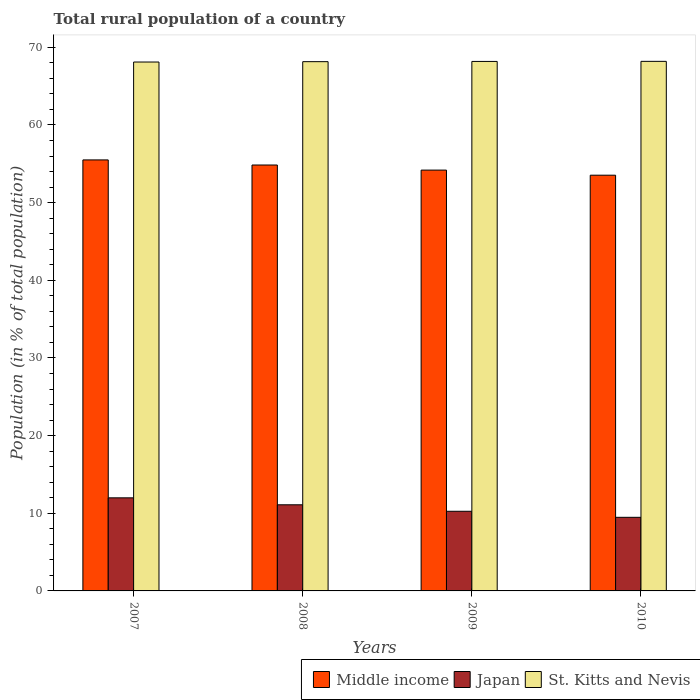How many groups of bars are there?
Give a very brief answer. 4. Are the number of bars per tick equal to the number of legend labels?
Ensure brevity in your answer.  Yes. How many bars are there on the 2nd tick from the left?
Provide a short and direct response. 3. What is the label of the 3rd group of bars from the left?
Make the answer very short. 2009. In how many cases, is the number of bars for a given year not equal to the number of legend labels?
Your answer should be compact. 0. What is the rural population in Japan in 2009?
Provide a succinct answer. 10.26. Across all years, what is the maximum rural population in Middle income?
Your answer should be very brief. 55.5. Across all years, what is the minimum rural population in St. Kitts and Nevis?
Offer a very short reply. 68.11. In which year was the rural population in St. Kitts and Nevis maximum?
Keep it short and to the point. 2010. In which year was the rural population in Japan minimum?
Your answer should be very brief. 2010. What is the total rural population in Japan in the graph?
Provide a succinct answer. 42.81. What is the difference between the rural population in Japan in 2008 and that in 2009?
Your answer should be compact. 0.83. What is the difference between the rural population in Middle income in 2007 and the rural population in Japan in 2008?
Offer a terse response. 44.41. What is the average rural population in St. Kitts and Nevis per year?
Give a very brief answer. 68.16. In the year 2009, what is the difference between the rural population in St. Kitts and Nevis and rural population in Japan?
Ensure brevity in your answer.  57.93. In how many years, is the rural population in Middle income greater than 4 %?
Offer a very short reply. 4. What is the ratio of the rural population in Middle income in 2008 to that in 2009?
Make the answer very short. 1.01. What is the difference between the highest and the second highest rural population in Middle income?
Provide a succinct answer. 0.66. What is the difference between the highest and the lowest rural population in Japan?
Ensure brevity in your answer.  2.51. In how many years, is the rural population in St. Kitts and Nevis greater than the average rural population in St. Kitts and Nevis taken over all years?
Give a very brief answer. 2. Is the sum of the rural population in Middle income in 2007 and 2010 greater than the maximum rural population in St. Kitts and Nevis across all years?
Provide a succinct answer. Yes. What does the 3rd bar from the left in 2009 represents?
Make the answer very short. St. Kitts and Nevis. What does the 1st bar from the right in 2007 represents?
Keep it short and to the point. St. Kitts and Nevis. How many bars are there?
Make the answer very short. 12. Are all the bars in the graph horizontal?
Your response must be concise. No. How many years are there in the graph?
Offer a terse response. 4. What is the difference between two consecutive major ticks on the Y-axis?
Provide a succinct answer. 10. Does the graph contain any zero values?
Make the answer very short. No. Does the graph contain grids?
Give a very brief answer. No. Where does the legend appear in the graph?
Ensure brevity in your answer.  Bottom right. How are the legend labels stacked?
Offer a terse response. Horizontal. What is the title of the graph?
Your answer should be compact. Total rural population of a country. Does "Albania" appear as one of the legend labels in the graph?
Offer a terse response. No. What is the label or title of the X-axis?
Offer a terse response. Years. What is the label or title of the Y-axis?
Make the answer very short. Population (in % of total population). What is the Population (in % of total population) in Middle income in 2007?
Keep it short and to the point. 55.5. What is the Population (in % of total population) in Japan in 2007?
Make the answer very short. 11.99. What is the Population (in % of total population) in St. Kitts and Nevis in 2007?
Ensure brevity in your answer.  68.11. What is the Population (in % of total population) in Middle income in 2008?
Give a very brief answer. 54.85. What is the Population (in % of total population) in Japan in 2008?
Your response must be concise. 11.09. What is the Population (in % of total population) in St. Kitts and Nevis in 2008?
Provide a succinct answer. 68.16. What is the Population (in % of total population) in Middle income in 2009?
Your response must be concise. 54.19. What is the Population (in % of total population) in Japan in 2009?
Your answer should be very brief. 10.26. What is the Population (in % of total population) of St. Kitts and Nevis in 2009?
Keep it short and to the point. 68.18. What is the Population (in % of total population) of Middle income in 2010?
Give a very brief answer. 53.53. What is the Population (in % of total population) of Japan in 2010?
Keep it short and to the point. 9.48. What is the Population (in % of total population) of St. Kitts and Nevis in 2010?
Provide a short and direct response. 68.19. Across all years, what is the maximum Population (in % of total population) of Middle income?
Provide a succinct answer. 55.5. Across all years, what is the maximum Population (in % of total population) of Japan?
Make the answer very short. 11.99. Across all years, what is the maximum Population (in % of total population) of St. Kitts and Nevis?
Offer a very short reply. 68.19. Across all years, what is the minimum Population (in % of total population) of Middle income?
Your answer should be compact. 53.53. Across all years, what is the minimum Population (in % of total population) of Japan?
Offer a terse response. 9.48. Across all years, what is the minimum Population (in % of total population) in St. Kitts and Nevis?
Offer a very short reply. 68.11. What is the total Population (in % of total population) in Middle income in the graph?
Give a very brief answer. 218.07. What is the total Population (in % of total population) of Japan in the graph?
Ensure brevity in your answer.  42.81. What is the total Population (in % of total population) of St. Kitts and Nevis in the graph?
Give a very brief answer. 272.64. What is the difference between the Population (in % of total population) of Middle income in 2007 and that in 2008?
Give a very brief answer. 0.66. What is the difference between the Population (in % of total population) of Japan in 2007 and that in 2008?
Give a very brief answer. 0.9. What is the difference between the Population (in % of total population) in St. Kitts and Nevis in 2007 and that in 2008?
Ensure brevity in your answer.  -0.05. What is the difference between the Population (in % of total population) of Middle income in 2007 and that in 2009?
Make the answer very short. 1.31. What is the difference between the Population (in % of total population) of Japan in 2007 and that in 2009?
Provide a succinct answer. 1.73. What is the difference between the Population (in % of total population) in St. Kitts and Nevis in 2007 and that in 2009?
Offer a terse response. -0.08. What is the difference between the Population (in % of total population) of Middle income in 2007 and that in 2010?
Provide a short and direct response. 1.97. What is the difference between the Population (in % of total population) of Japan in 2007 and that in 2010?
Provide a succinct answer. 2.51. What is the difference between the Population (in % of total population) in St. Kitts and Nevis in 2007 and that in 2010?
Offer a very short reply. -0.09. What is the difference between the Population (in % of total population) in Middle income in 2008 and that in 2009?
Offer a terse response. 0.66. What is the difference between the Population (in % of total population) of Japan in 2008 and that in 2009?
Make the answer very short. 0.83. What is the difference between the Population (in % of total population) of St. Kitts and Nevis in 2008 and that in 2009?
Offer a very short reply. -0.03. What is the difference between the Population (in % of total population) of Middle income in 2008 and that in 2010?
Offer a very short reply. 1.31. What is the difference between the Population (in % of total population) in Japan in 2008 and that in 2010?
Give a very brief answer. 1.61. What is the difference between the Population (in % of total population) of St. Kitts and Nevis in 2008 and that in 2010?
Your answer should be very brief. -0.04. What is the difference between the Population (in % of total population) in Middle income in 2009 and that in 2010?
Your answer should be very brief. 0.66. What is the difference between the Population (in % of total population) of Japan in 2009 and that in 2010?
Provide a short and direct response. 0.78. What is the difference between the Population (in % of total population) in St. Kitts and Nevis in 2009 and that in 2010?
Offer a very short reply. -0.01. What is the difference between the Population (in % of total population) in Middle income in 2007 and the Population (in % of total population) in Japan in 2008?
Your answer should be compact. 44.41. What is the difference between the Population (in % of total population) of Middle income in 2007 and the Population (in % of total population) of St. Kitts and Nevis in 2008?
Your answer should be very brief. -12.65. What is the difference between the Population (in % of total population) in Japan in 2007 and the Population (in % of total population) in St. Kitts and Nevis in 2008?
Your answer should be compact. -56.17. What is the difference between the Population (in % of total population) in Middle income in 2007 and the Population (in % of total population) in Japan in 2009?
Make the answer very short. 45.25. What is the difference between the Population (in % of total population) in Middle income in 2007 and the Population (in % of total population) in St. Kitts and Nevis in 2009?
Ensure brevity in your answer.  -12.68. What is the difference between the Population (in % of total population) in Japan in 2007 and the Population (in % of total population) in St. Kitts and Nevis in 2009?
Keep it short and to the point. -56.2. What is the difference between the Population (in % of total population) of Middle income in 2007 and the Population (in % of total population) of Japan in 2010?
Provide a short and direct response. 46.02. What is the difference between the Population (in % of total population) in Middle income in 2007 and the Population (in % of total population) in St. Kitts and Nevis in 2010?
Your answer should be very brief. -12.69. What is the difference between the Population (in % of total population) of Japan in 2007 and the Population (in % of total population) of St. Kitts and Nevis in 2010?
Provide a short and direct response. -56.21. What is the difference between the Population (in % of total population) of Middle income in 2008 and the Population (in % of total population) of Japan in 2009?
Your response must be concise. 44.59. What is the difference between the Population (in % of total population) of Middle income in 2008 and the Population (in % of total population) of St. Kitts and Nevis in 2009?
Make the answer very short. -13.34. What is the difference between the Population (in % of total population) in Japan in 2008 and the Population (in % of total population) in St. Kitts and Nevis in 2009?
Offer a very short reply. -57.09. What is the difference between the Population (in % of total population) in Middle income in 2008 and the Population (in % of total population) in Japan in 2010?
Make the answer very short. 45.37. What is the difference between the Population (in % of total population) in Middle income in 2008 and the Population (in % of total population) in St. Kitts and Nevis in 2010?
Your answer should be compact. -13.35. What is the difference between the Population (in % of total population) of Japan in 2008 and the Population (in % of total population) of St. Kitts and Nevis in 2010?
Offer a very short reply. -57.1. What is the difference between the Population (in % of total population) of Middle income in 2009 and the Population (in % of total population) of Japan in 2010?
Offer a terse response. 44.71. What is the difference between the Population (in % of total population) of Middle income in 2009 and the Population (in % of total population) of St. Kitts and Nevis in 2010?
Offer a very short reply. -14. What is the difference between the Population (in % of total population) of Japan in 2009 and the Population (in % of total population) of St. Kitts and Nevis in 2010?
Your answer should be compact. -57.94. What is the average Population (in % of total population) of Middle income per year?
Give a very brief answer. 54.52. What is the average Population (in % of total population) in Japan per year?
Provide a succinct answer. 10.7. What is the average Population (in % of total population) of St. Kitts and Nevis per year?
Give a very brief answer. 68.16. In the year 2007, what is the difference between the Population (in % of total population) in Middle income and Population (in % of total population) in Japan?
Keep it short and to the point. 43.52. In the year 2007, what is the difference between the Population (in % of total population) of Middle income and Population (in % of total population) of St. Kitts and Nevis?
Keep it short and to the point. -12.6. In the year 2007, what is the difference between the Population (in % of total population) of Japan and Population (in % of total population) of St. Kitts and Nevis?
Provide a succinct answer. -56.12. In the year 2008, what is the difference between the Population (in % of total population) of Middle income and Population (in % of total population) of Japan?
Provide a short and direct response. 43.76. In the year 2008, what is the difference between the Population (in % of total population) in Middle income and Population (in % of total population) in St. Kitts and Nevis?
Give a very brief answer. -13.31. In the year 2008, what is the difference between the Population (in % of total population) of Japan and Population (in % of total population) of St. Kitts and Nevis?
Keep it short and to the point. -57.06. In the year 2009, what is the difference between the Population (in % of total population) of Middle income and Population (in % of total population) of Japan?
Make the answer very short. 43.93. In the year 2009, what is the difference between the Population (in % of total population) of Middle income and Population (in % of total population) of St. Kitts and Nevis?
Your answer should be very brief. -13.99. In the year 2009, what is the difference between the Population (in % of total population) in Japan and Population (in % of total population) in St. Kitts and Nevis?
Keep it short and to the point. -57.93. In the year 2010, what is the difference between the Population (in % of total population) of Middle income and Population (in % of total population) of Japan?
Ensure brevity in your answer.  44.06. In the year 2010, what is the difference between the Population (in % of total population) in Middle income and Population (in % of total population) in St. Kitts and Nevis?
Provide a succinct answer. -14.66. In the year 2010, what is the difference between the Population (in % of total population) in Japan and Population (in % of total population) in St. Kitts and Nevis?
Your answer should be very brief. -58.72. What is the ratio of the Population (in % of total population) in Japan in 2007 to that in 2008?
Offer a very short reply. 1.08. What is the ratio of the Population (in % of total population) of St. Kitts and Nevis in 2007 to that in 2008?
Offer a very short reply. 1. What is the ratio of the Population (in % of total population) in Middle income in 2007 to that in 2009?
Your answer should be very brief. 1.02. What is the ratio of the Population (in % of total population) in Japan in 2007 to that in 2009?
Your response must be concise. 1.17. What is the ratio of the Population (in % of total population) in St. Kitts and Nevis in 2007 to that in 2009?
Your answer should be very brief. 1. What is the ratio of the Population (in % of total population) in Middle income in 2007 to that in 2010?
Offer a very short reply. 1.04. What is the ratio of the Population (in % of total population) of Japan in 2007 to that in 2010?
Your answer should be compact. 1.26. What is the ratio of the Population (in % of total population) of Middle income in 2008 to that in 2009?
Keep it short and to the point. 1.01. What is the ratio of the Population (in % of total population) of Japan in 2008 to that in 2009?
Provide a short and direct response. 1.08. What is the ratio of the Population (in % of total population) of Middle income in 2008 to that in 2010?
Offer a terse response. 1.02. What is the ratio of the Population (in % of total population) of Japan in 2008 to that in 2010?
Offer a terse response. 1.17. What is the ratio of the Population (in % of total population) of St. Kitts and Nevis in 2008 to that in 2010?
Provide a succinct answer. 1. What is the ratio of the Population (in % of total population) of Middle income in 2009 to that in 2010?
Make the answer very short. 1.01. What is the ratio of the Population (in % of total population) in Japan in 2009 to that in 2010?
Offer a very short reply. 1.08. What is the ratio of the Population (in % of total population) of St. Kitts and Nevis in 2009 to that in 2010?
Make the answer very short. 1. What is the difference between the highest and the second highest Population (in % of total population) of Middle income?
Your response must be concise. 0.66. What is the difference between the highest and the second highest Population (in % of total population) in Japan?
Your answer should be very brief. 0.9. What is the difference between the highest and the lowest Population (in % of total population) in Middle income?
Your response must be concise. 1.97. What is the difference between the highest and the lowest Population (in % of total population) in Japan?
Your response must be concise. 2.51. What is the difference between the highest and the lowest Population (in % of total population) of St. Kitts and Nevis?
Offer a terse response. 0.09. 